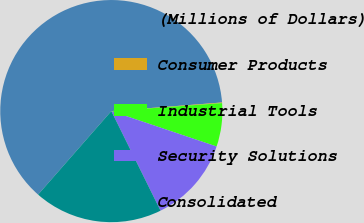<chart> <loc_0><loc_0><loc_500><loc_500><pie_chart><fcel>(Millions of Dollars)<fcel>Consumer Products<fcel>Industrial Tools<fcel>Security Solutions<fcel>Consolidated<nl><fcel>62.3%<fcel>0.09%<fcel>6.31%<fcel>12.53%<fcel>18.76%<nl></chart> 